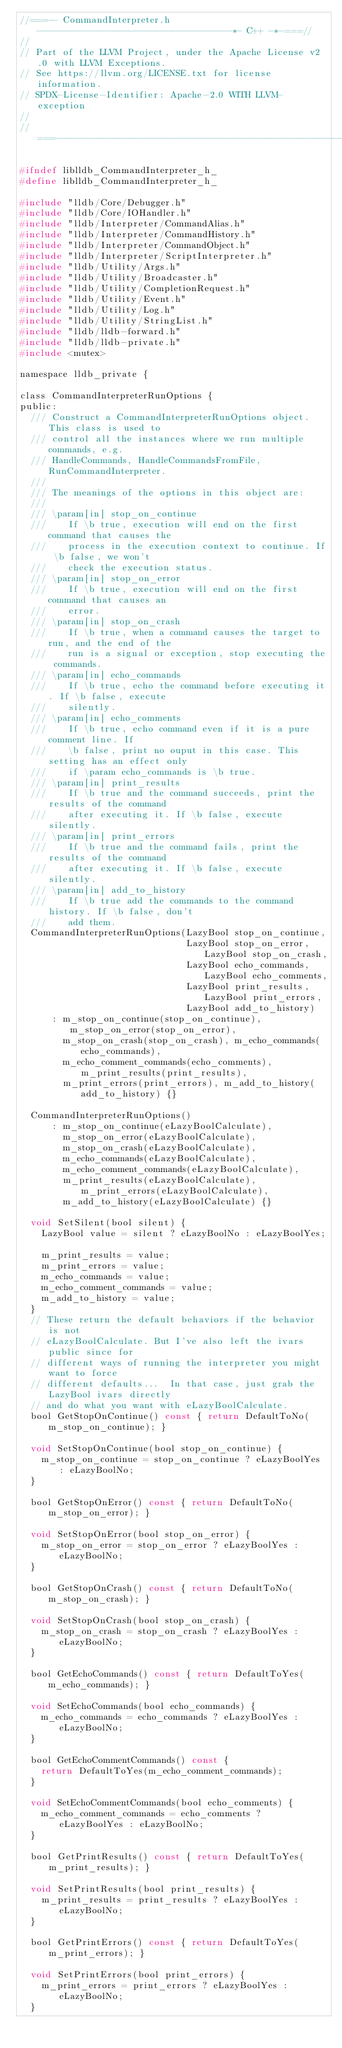Convert code to text. <code><loc_0><loc_0><loc_500><loc_500><_C_>//===-- CommandInterpreter.h ------------------------------------*- C++ -*-===//
//
// Part of the LLVM Project, under the Apache License v2.0 with LLVM Exceptions.
// See https://llvm.org/LICENSE.txt for license information.
// SPDX-License-Identifier: Apache-2.0 WITH LLVM-exception
//
//===----------------------------------------------------------------------===//

#ifndef liblldb_CommandInterpreter_h_
#define liblldb_CommandInterpreter_h_

#include "lldb/Core/Debugger.h"
#include "lldb/Core/IOHandler.h"
#include "lldb/Interpreter/CommandAlias.h"
#include "lldb/Interpreter/CommandHistory.h"
#include "lldb/Interpreter/CommandObject.h"
#include "lldb/Interpreter/ScriptInterpreter.h"
#include "lldb/Utility/Args.h"
#include "lldb/Utility/Broadcaster.h"
#include "lldb/Utility/CompletionRequest.h"
#include "lldb/Utility/Event.h"
#include "lldb/Utility/Log.h"
#include "lldb/Utility/StringList.h"
#include "lldb/lldb-forward.h"
#include "lldb/lldb-private.h"
#include <mutex>

namespace lldb_private {

class CommandInterpreterRunOptions {
public:
  /// Construct a CommandInterpreterRunOptions object. This class is used to
  /// control all the instances where we run multiple commands, e.g.
  /// HandleCommands, HandleCommandsFromFile, RunCommandInterpreter.
  ///
  /// The meanings of the options in this object are:
  ///
  /// \param[in] stop_on_continue
  ///    If \b true, execution will end on the first command that causes the
  ///    process in the execution context to continue. If \b false, we won't
  ///    check the execution status.
  /// \param[in] stop_on_error
  ///    If \b true, execution will end on the first command that causes an
  ///    error.
  /// \param[in] stop_on_crash
  ///    If \b true, when a command causes the target to run, and the end of the
  ///    run is a signal or exception, stop executing the commands.
  /// \param[in] echo_commands
  ///    If \b true, echo the command before executing it. If \b false, execute
  ///    silently.
  /// \param[in] echo_comments
  ///    If \b true, echo command even if it is a pure comment line. If
  ///    \b false, print no ouput in this case. This setting has an effect only
  ///    if \param echo_commands is \b true.
  /// \param[in] print_results
  ///    If \b true and the command succeeds, print the results of the command
  ///    after executing it. If \b false, execute silently.
  /// \param[in] print_errors
  ///    If \b true and the command fails, print the results of the command
  ///    after executing it. If \b false, execute silently.
  /// \param[in] add_to_history
  ///    If \b true add the commands to the command history. If \b false, don't
  ///    add them.
  CommandInterpreterRunOptions(LazyBool stop_on_continue,
                               LazyBool stop_on_error, LazyBool stop_on_crash,
                               LazyBool echo_commands, LazyBool echo_comments,
                               LazyBool print_results, LazyBool print_errors,
                               LazyBool add_to_history)
      : m_stop_on_continue(stop_on_continue), m_stop_on_error(stop_on_error),
        m_stop_on_crash(stop_on_crash), m_echo_commands(echo_commands),
        m_echo_comment_commands(echo_comments), m_print_results(print_results),
        m_print_errors(print_errors), m_add_to_history(add_to_history) {}

  CommandInterpreterRunOptions()
      : m_stop_on_continue(eLazyBoolCalculate),
        m_stop_on_error(eLazyBoolCalculate),
        m_stop_on_crash(eLazyBoolCalculate),
        m_echo_commands(eLazyBoolCalculate),
        m_echo_comment_commands(eLazyBoolCalculate),
        m_print_results(eLazyBoolCalculate), m_print_errors(eLazyBoolCalculate),
        m_add_to_history(eLazyBoolCalculate) {}

  void SetSilent(bool silent) {
    LazyBool value = silent ? eLazyBoolNo : eLazyBoolYes;

    m_print_results = value;
    m_print_errors = value;
    m_echo_commands = value;
    m_echo_comment_commands = value;
    m_add_to_history = value;
  }
  // These return the default behaviors if the behavior is not
  // eLazyBoolCalculate. But I've also left the ivars public since for
  // different ways of running the interpreter you might want to force
  // different defaults...  In that case, just grab the LazyBool ivars directly
  // and do what you want with eLazyBoolCalculate.
  bool GetStopOnContinue() const { return DefaultToNo(m_stop_on_continue); }

  void SetStopOnContinue(bool stop_on_continue) {
    m_stop_on_continue = stop_on_continue ? eLazyBoolYes : eLazyBoolNo;
  }

  bool GetStopOnError() const { return DefaultToNo(m_stop_on_error); }

  void SetStopOnError(bool stop_on_error) {
    m_stop_on_error = stop_on_error ? eLazyBoolYes : eLazyBoolNo;
  }

  bool GetStopOnCrash() const { return DefaultToNo(m_stop_on_crash); }

  void SetStopOnCrash(bool stop_on_crash) {
    m_stop_on_crash = stop_on_crash ? eLazyBoolYes : eLazyBoolNo;
  }

  bool GetEchoCommands() const { return DefaultToYes(m_echo_commands); }

  void SetEchoCommands(bool echo_commands) {
    m_echo_commands = echo_commands ? eLazyBoolYes : eLazyBoolNo;
  }

  bool GetEchoCommentCommands() const {
    return DefaultToYes(m_echo_comment_commands);
  }

  void SetEchoCommentCommands(bool echo_comments) {
    m_echo_comment_commands = echo_comments ? eLazyBoolYes : eLazyBoolNo;
  }

  bool GetPrintResults() const { return DefaultToYes(m_print_results); }

  void SetPrintResults(bool print_results) {
    m_print_results = print_results ? eLazyBoolYes : eLazyBoolNo;
  }

  bool GetPrintErrors() const { return DefaultToYes(m_print_errors); }

  void SetPrintErrors(bool print_errors) {
    m_print_errors = print_errors ? eLazyBoolYes : eLazyBoolNo;
  }
</code> 